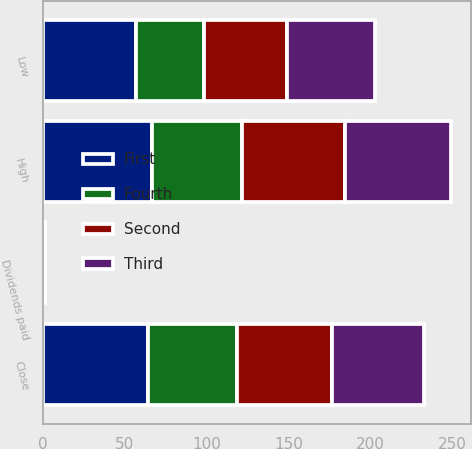<chart> <loc_0><loc_0><loc_500><loc_500><stacked_bar_chart><ecel><fcel>High<fcel>Low<fcel>Close<fcel>Dividends paid<nl><fcel>Fourth<fcel>54.54<fcel>41.57<fcel>54.26<fcel>0.33<nl><fcel>Second<fcel>63.39<fcel>50.37<fcel>58.29<fcel>0.33<nl><fcel>First<fcel>66.99<fcel>57.2<fcel>64.24<fcel>0.34<nl><fcel>Third<fcel>64.39<fcel>53.8<fcel>56.07<fcel>0.34<nl></chart> 